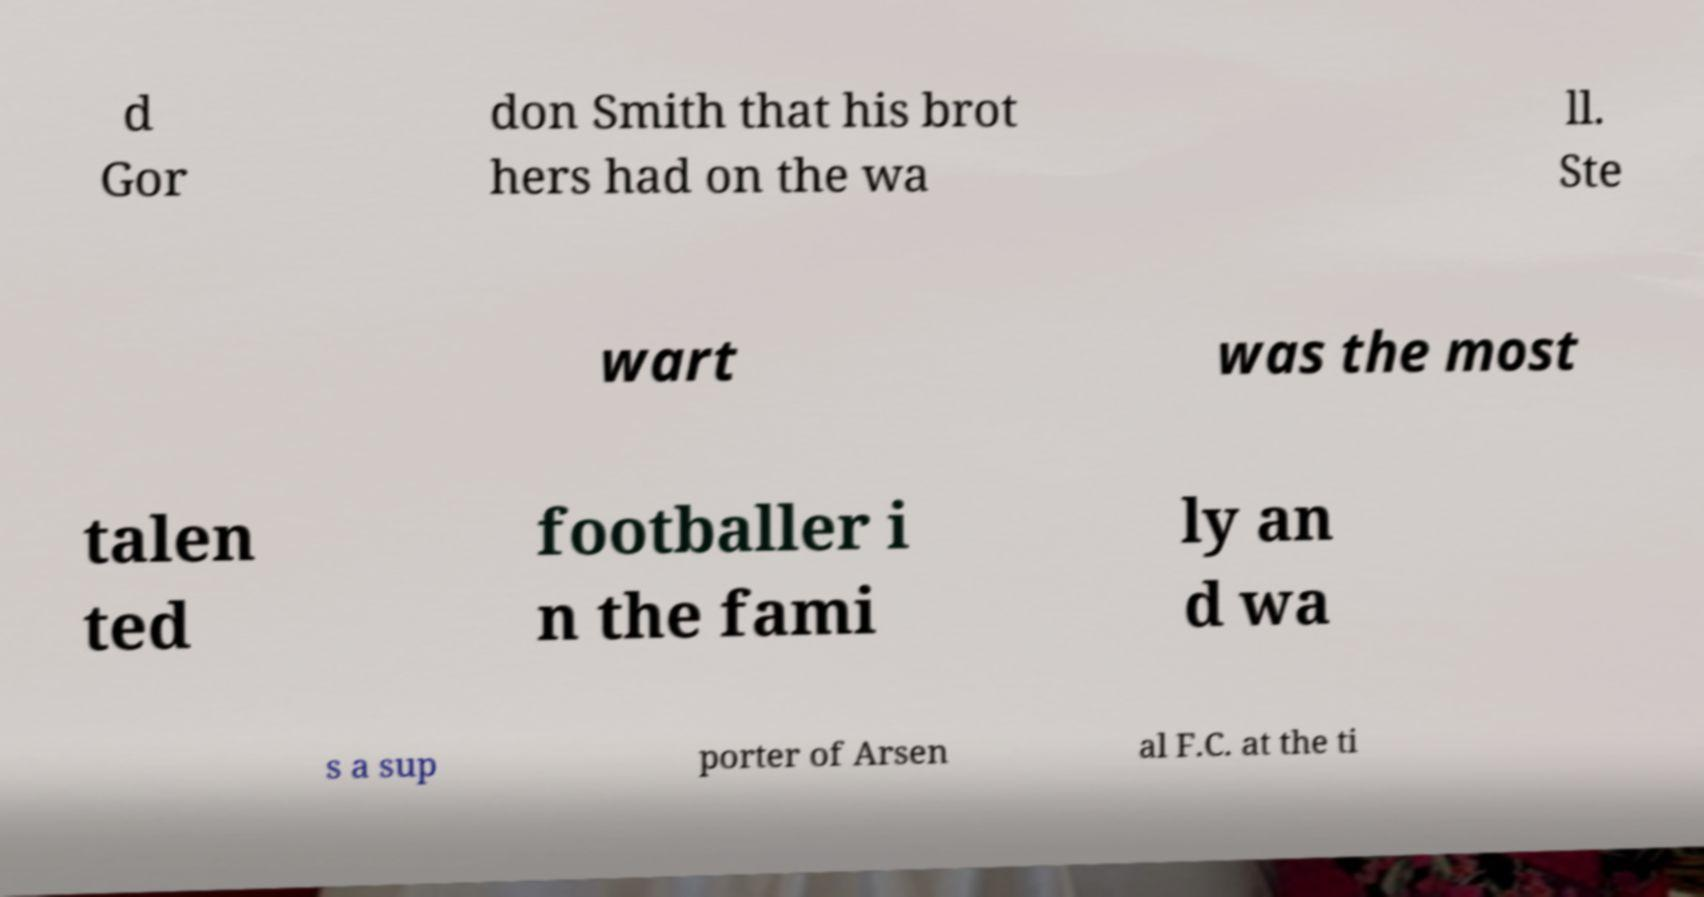Could you extract and type out the text from this image? d Gor don Smith that his brot hers had on the wa ll. Ste wart was the most talen ted footballer i n the fami ly an d wa s a sup porter of Arsen al F.C. at the ti 